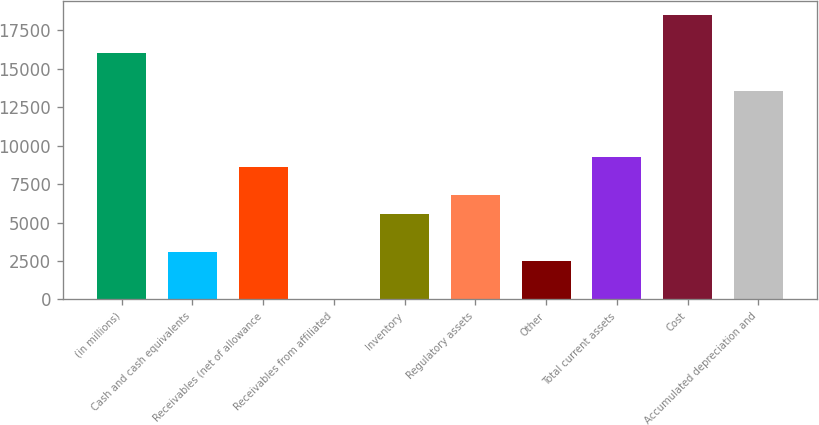Convert chart to OTSL. <chart><loc_0><loc_0><loc_500><loc_500><bar_chart><fcel>(in millions)<fcel>Cash and cash equivalents<fcel>Receivables (net of allowance<fcel>Receivables from affiliated<fcel>Inventory<fcel>Regulatory assets<fcel>Other<fcel>Total current assets<fcel>Cost<fcel>Accumulated depreciation and<nl><fcel>16041.2<fcel>3090.5<fcel>8640.8<fcel>7<fcel>5557.3<fcel>6790.7<fcel>2473.8<fcel>9257.5<fcel>18508<fcel>13574.4<nl></chart> 